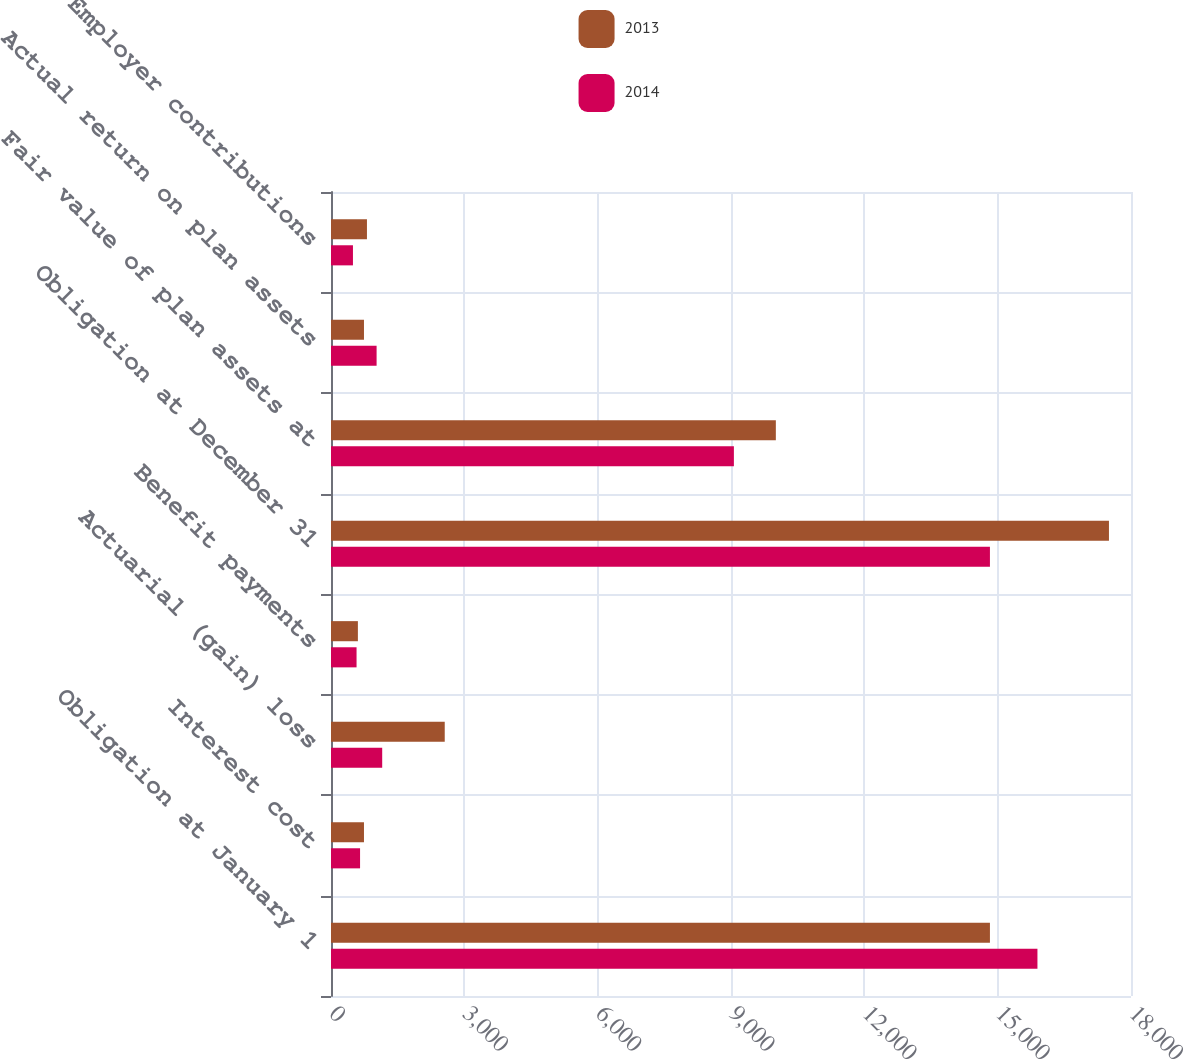<chart> <loc_0><loc_0><loc_500><loc_500><stacked_bar_chart><ecel><fcel>Obligation at January 1<fcel>Interest cost<fcel>Actuarial (gain) loss<fcel>Benefit payments<fcel>Obligation at December 31<fcel>Fair value of plan assets at<fcel>Actual return on plan assets<fcel>Employer contributions<nl><fcel>2013<fcel>14826<fcel>742<fcel>2559<fcel>605<fcel>17504<fcel>10009<fcel>742<fcel>809<nl><fcel>2014<fcel>15895<fcel>654<fcel>1152<fcel>575<fcel>14826<fcel>9065<fcel>1026<fcel>494<nl></chart> 